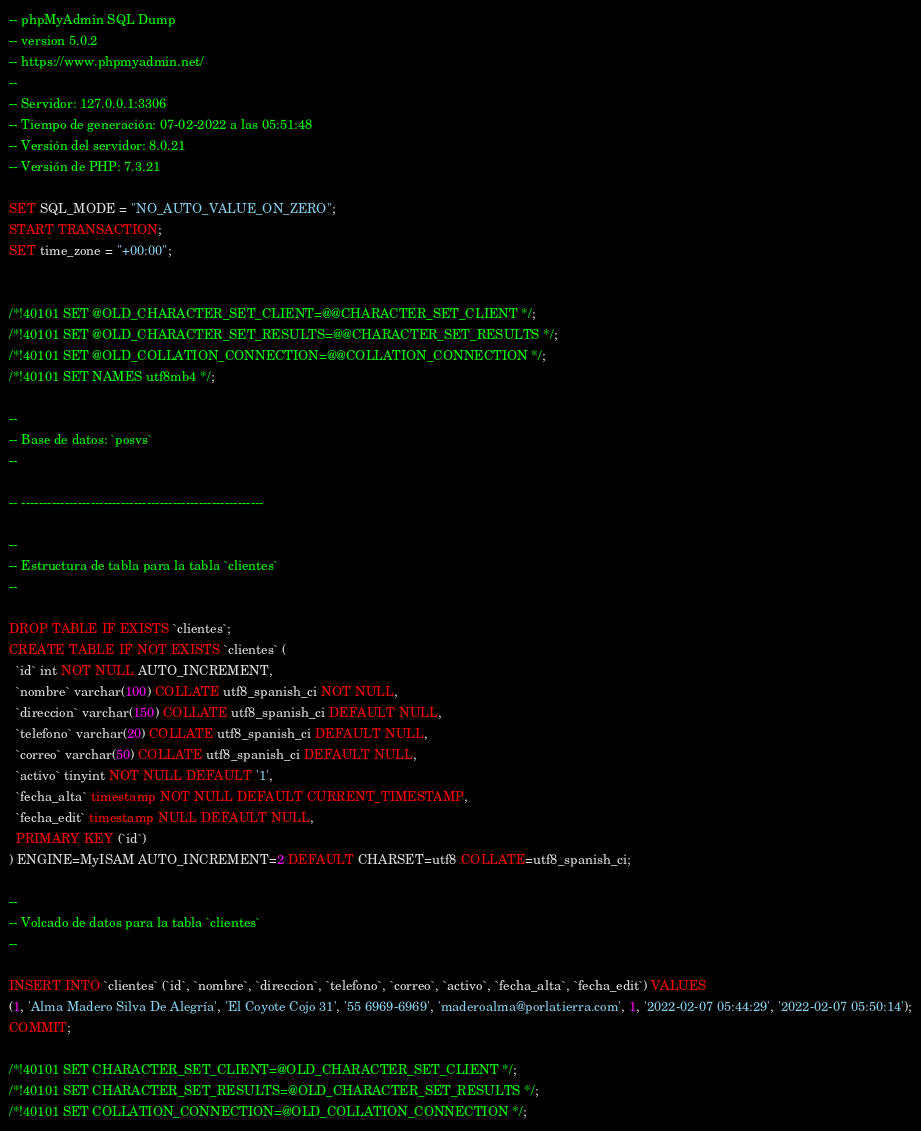Convert code to text. <code><loc_0><loc_0><loc_500><loc_500><_SQL_>-- phpMyAdmin SQL Dump
-- version 5.0.2
-- https://www.phpmyadmin.net/
--
-- Servidor: 127.0.0.1:3306
-- Tiempo de generación: 07-02-2022 a las 05:51:48
-- Versión del servidor: 8.0.21
-- Versión de PHP: 7.3.21

SET SQL_MODE = "NO_AUTO_VALUE_ON_ZERO";
START TRANSACTION;
SET time_zone = "+00:00";


/*!40101 SET @OLD_CHARACTER_SET_CLIENT=@@CHARACTER_SET_CLIENT */;
/*!40101 SET @OLD_CHARACTER_SET_RESULTS=@@CHARACTER_SET_RESULTS */;
/*!40101 SET @OLD_COLLATION_CONNECTION=@@COLLATION_CONNECTION */;
/*!40101 SET NAMES utf8mb4 */;

--
-- Base de datos: `posvs`
--

-- --------------------------------------------------------

--
-- Estructura de tabla para la tabla `clientes`
--

DROP TABLE IF EXISTS `clientes`;
CREATE TABLE IF NOT EXISTS `clientes` (
  `id` int NOT NULL AUTO_INCREMENT,
  `nombre` varchar(100) COLLATE utf8_spanish_ci NOT NULL,
  `direccion` varchar(150) COLLATE utf8_spanish_ci DEFAULT NULL,
  `telefono` varchar(20) COLLATE utf8_spanish_ci DEFAULT NULL,
  `correo` varchar(50) COLLATE utf8_spanish_ci DEFAULT NULL,
  `activo` tinyint NOT NULL DEFAULT '1',
  `fecha_alta` timestamp NOT NULL DEFAULT CURRENT_TIMESTAMP,
  `fecha_edit` timestamp NULL DEFAULT NULL,
  PRIMARY KEY (`id`)
) ENGINE=MyISAM AUTO_INCREMENT=2 DEFAULT CHARSET=utf8 COLLATE=utf8_spanish_ci;

--
-- Volcado de datos para la tabla `clientes`
--

INSERT INTO `clientes` (`id`, `nombre`, `direccion`, `telefono`, `correo`, `activo`, `fecha_alta`, `fecha_edit`) VALUES
(1, 'Alma Madero Silva De Alegría', 'El Coyote Cojo 31', '55 6969-6969', 'maderoalma@porlatierra.com', 1, '2022-02-07 05:44:29', '2022-02-07 05:50:14');
COMMIT;

/*!40101 SET CHARACTER_SET_CLIENT=@OLD_CHARACTER_SET_CLIENT */;
/*!40101 SET CHARACTER_SET_RESULTS=@OLD_CHARACTER_SET_RESULTS */;
/*!40101 SET COLLATION_CONNECTION=@OLD_COLLATION_CONNECTION */;
</code> 